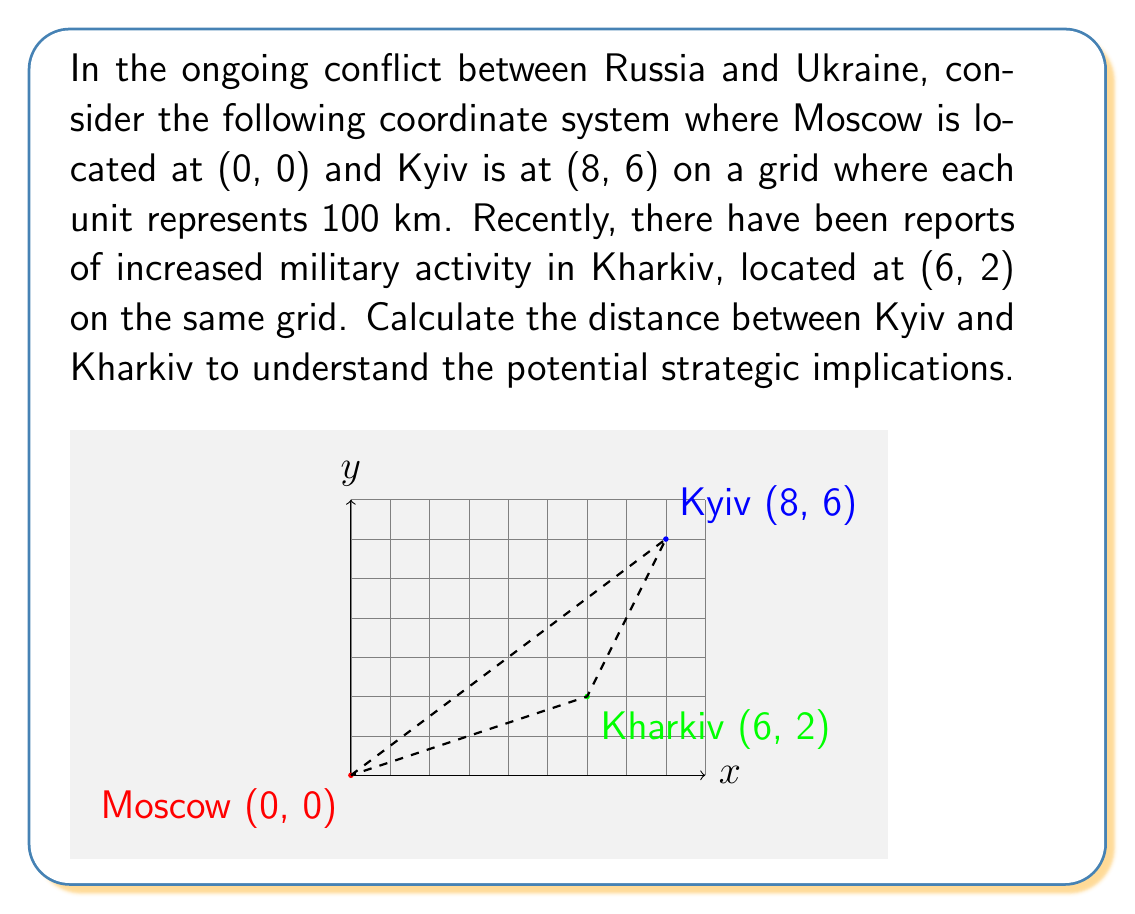Show me your answer to this math problem. To find the distance between Kyiv and Kharkiv, we can use the distance formula derived from the Pythagorean theorem:

$$d = \sqrt{(x_2 - x_1)^2 + (y_2 - y_1)^2}$$

Where $(x_1, y_1)$ are the coordinates of Kyiv (8, 6) and $(x_2, y_2)$ are the coordinates of Kharkiv (6, 2).

Step 1: Substitute the coordinates into the formula:
$$d = \sqrt{(6 - 8)^2 + (2 - 6)^2}$$

Step 2: Simplify the expressions inside the parentheses:
$$d = \sqrt{(-2)^2 + (-4)^2}$$

Step 3: Calculate the squares:
$$d = \sqrt{4 + 16}$$

Step 4: Add under the square root:
$$d = \sqrt{20}$$

Step 5: Simplify the square root:
$$d = 2\sqrt{5}$$

Since each unit represents 100 km, we multiply our result by 100:

$$d = 2\sqrt{5} \times 100 = 200\sqrt{5} \text{ km}$$

This is approximately 447.21 km.
Answer: $200\sqrt{5}$ km or approximately 447.21 km 